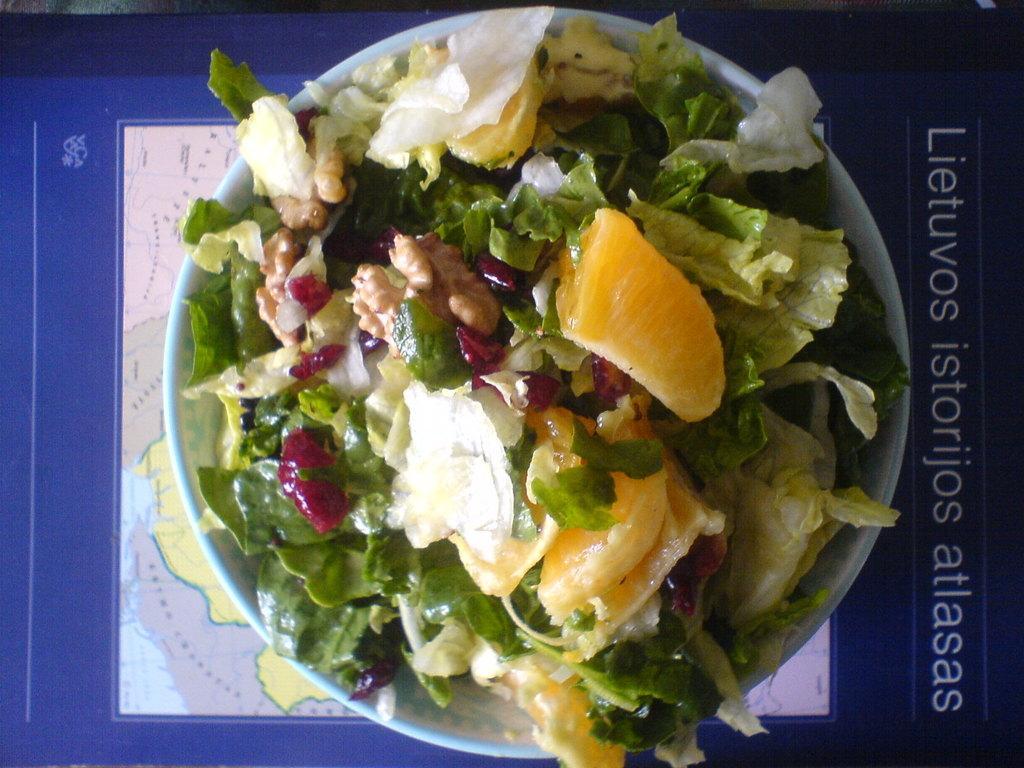In one or two sentences, can you explain what this image depicts? In this image there is a food item in a bowl on a blue colored surface. 